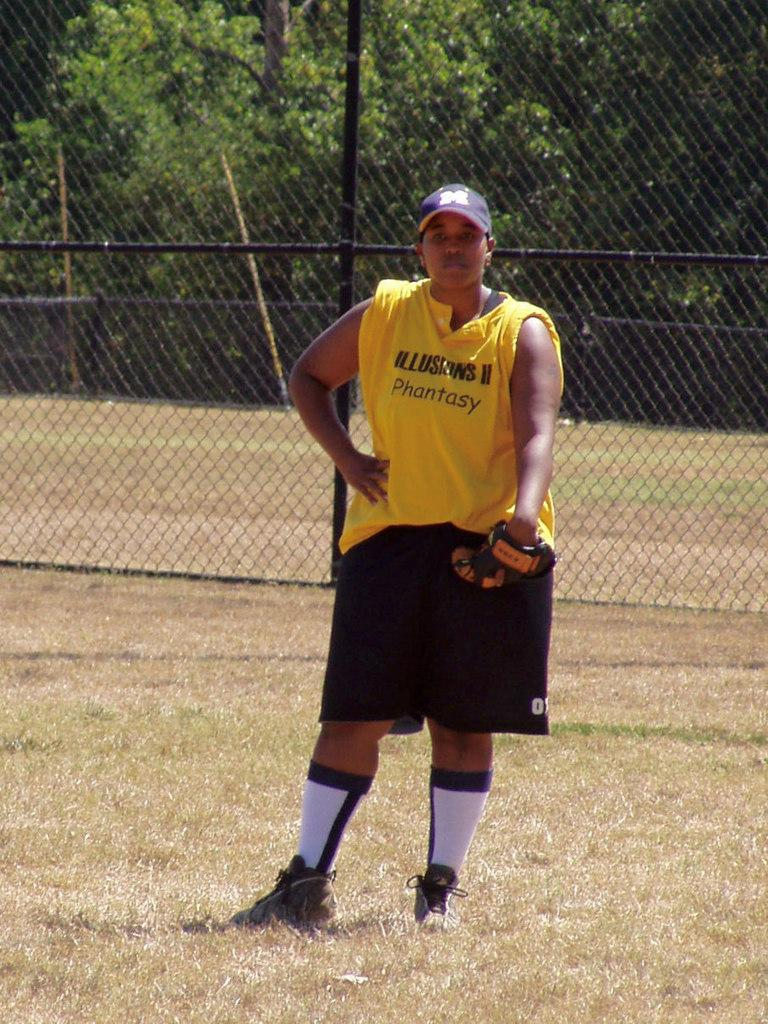Provide a one-sentence caption for the provided image. A boy with a catcher's mitt is standing in a field and his shirt says Phantasy. 